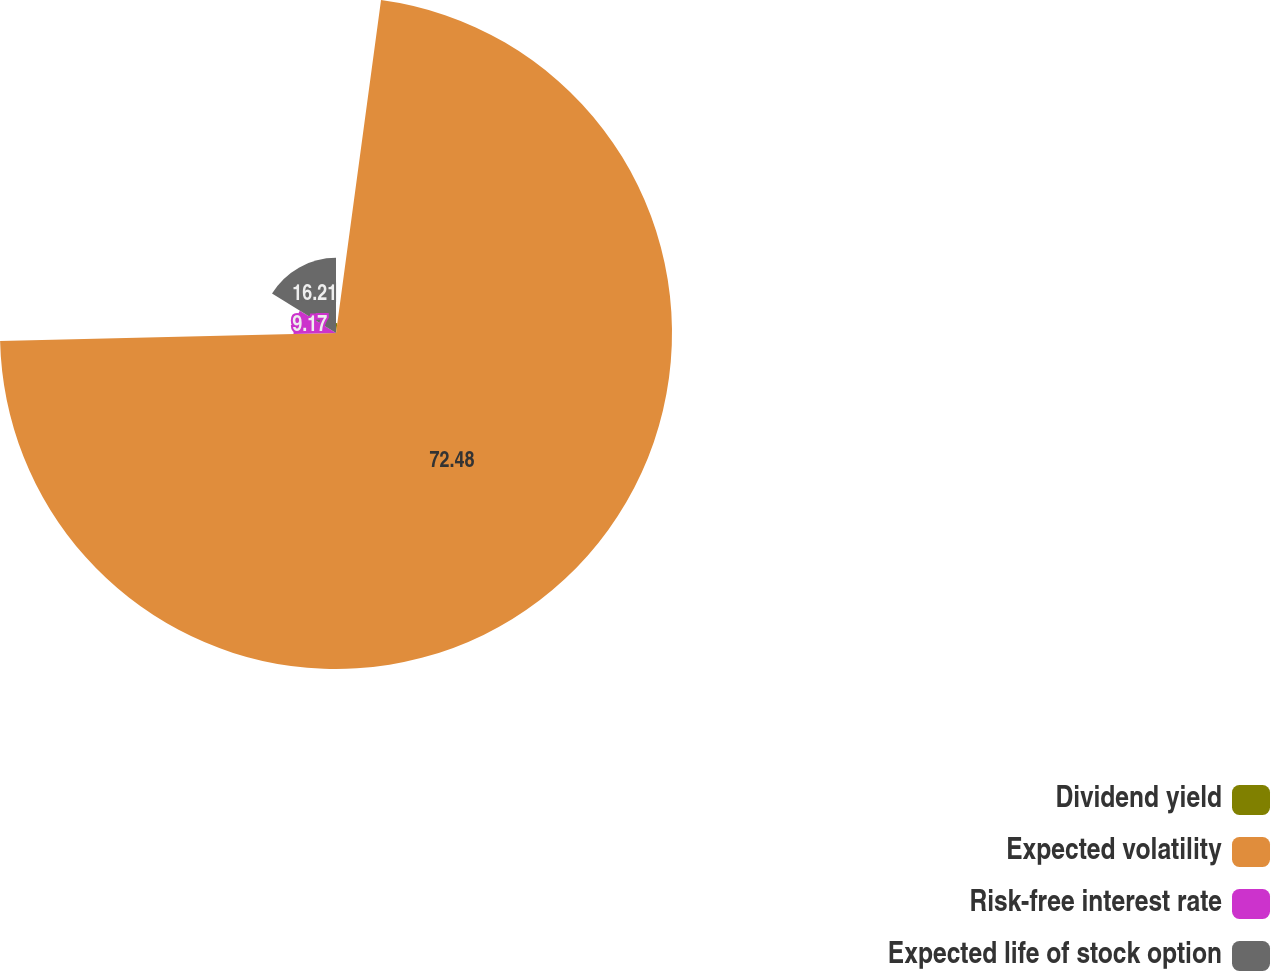<chart> <loc_0><loc_0><loc_500><loc_500><pie_chart><fcel>Dividend yield<fcel>Expected volatility<fcel>Risk-free interest rate<fcel>Expected life of stock option<nl><fcel>2.14%<fcel>72.48%<fcel>9.17%<fcel>16.21%<nl></chart> 